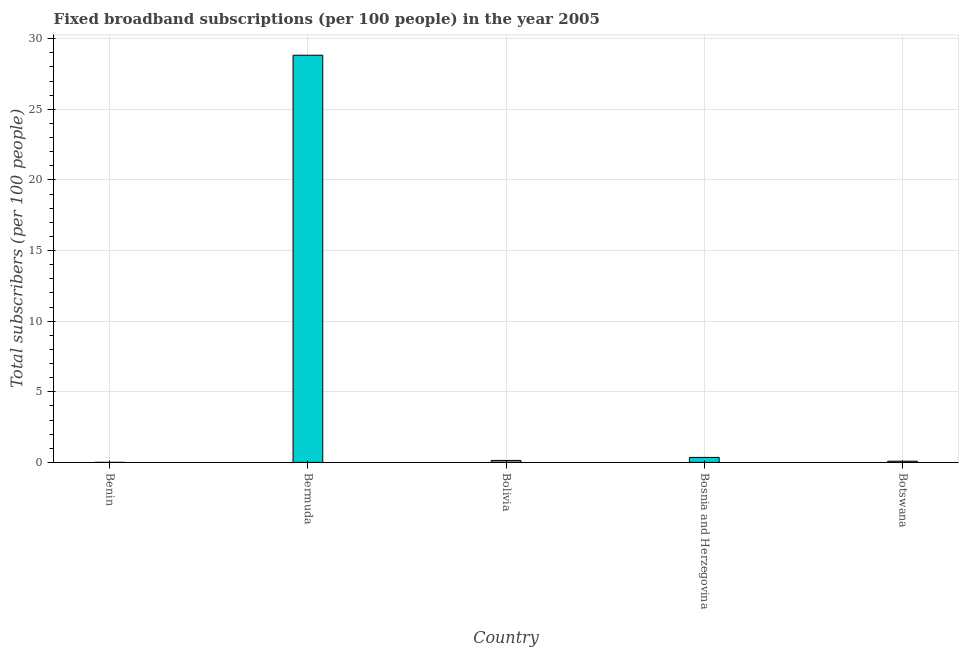Does the graph contain grids?
Give a very brief answer. Yes. What is the title of the graph?
Your answer should be compact. Fixed broadband subscriptions (per 100 people) in the year 2005. What is the label or title of the X-axis?
Provide a succinct answer. Country. What is the label or title of the Y-axis?
Offer a terse response. Total subscribers (per 100 people). What is the total number of fixed broadband subscriptions in Botswana?
Provide a succinct answer. 0.09. Across all countries, what is the maximum total number of fixed broadband subscriptions?
Make the answer very short. 28.82. Across all countries, what is the minimum total number of fixed broadband subscriptions?
Ensure brevity in your answer.  0. In which country was the total number of fixed broadband subscriptions maximum?
Offer a terse response. Bermuda. In which country was the total number of fixed broadband subscriptions minimum?
Make the answer very short. Benin. What is the sum of the total number of fixed broadband subscriptions?
Make the answer very short. 29.4. What is the difference between the total number of fixed broadband subscriptions in Bolivia and Bosnia and Herzegovina?
Your response must be concise. -0.21. What is the average total number of fixed broadband subscriptions per country?
Make the answer very short. 5.88. What is the median total number of fixed broadband subscriptions?
Offer a terse response. 0.14. What is the ratio of the total number of fixed broadband subscriptions in Bermuda to that in Bosnia and Herzegovina?
Your answer should be very brief. 81.62. Is the total number of fixed broadband subscriptions in Bermuda less than that in Bosnia and Herzegovina?
Provide a short and direct response. No. Is the difference between the total number of fixed broadband subscriptions in Bermuda and Bolivia greater than the difference between any two countries?
Your response must be concise. No. What is the difference between the highest and the second highest total number of fixed broadband subscriptions?
Provide a succinct answer. 28.47. What is the difference between the highest and the lowest total number of fixed broadband subscriptions?
Provide a short and direct response. 28.82. In how many countries, is the total number of fixed broadband subscriptions greater than the average total number of fixed broadband subscriptions taken over all countries?
Your answer should be compact. 1. What is the difference between two consecutive major ticks on the Y-axis?
Offer a terse response. 5. Are the values on the major ticks of Y-axis written in scientific E-notation?
Your answer should be compact. No. What is the Total subscribers (per 100 people) of Benin?
Offer a very short reply. 0. What is the Total subscribers (per 100 people) in Bermuda?
Offer a very short reply. 28.82. What is the Total subscribers (per 100 people) in Bolivia?
Provide a succinct answer. 0.14. What is the Total subscribers (per 100 people) of Bosnia and Herzegovina?
Your answer should be compact. 0.35. What is the Total subscribers (per 100 people) of Botswana?
Provide a succinct answer. 0.09. What is the difference between the Total subscribers (per 100 people) in Benin and Bermuda?
Ensure brevity in your answer.  -28.82. What is the difference between the Total subscribers (per 100 people) in Benin and Bolivia?
Provide a short and direct response. -0.14. What is the difference between the Total subscribers (per 100 people) in Benin and Bosnia and Herzegovina?
Offer a terse response. -0.35. What is the difference between the Total subscribers (per 100 people) in Benin and Botswana?
Provide a succinct answer. -0.08. What is the difference between the Total subscribers (per 100 people) in Bermuda and Bolivia?
Your response must be concise. 28.69. What is the difference between the Total subscribers (per 100 people) in Bermuda and Bosnia and Herzegovina?
Your answer should be very brief. 28.47. What is the difference between the Total subscribers (per 100 people) in Bermuda and Botswana?
Your answer should be compact. 28.74. What is the difference between the Total subscribers (per 100 people) in Bolivia and Bosnia and Herzegovina?
Give a very brief answer. -0.21. What is the difference between the Total subscribers (per 100 people) in Bolivia and Botswana?
Your response must be concise. 0.05. What is the difference between the Total subscribers (per 100 people) in Bosnia and Herzegovina and Botswana?
Your response must be concise. 0.27. What is the ratio of the Total subscribers (per 100 people) in Benin to that in Bolivia?
Your answer should be compact. 0.02. What is the ratio of the Total subscribers (per 100 people) in Benin to that in Bosnia and Herzegovina?
Your answer should be very brief. 0.01. What is the ratio of the Total subscribers (per 100 people) in Benin to that in Botswana?
Provide a short and direct response. 0.03. What is the ratio of the Total subscribers (per 100 people) in Bermuda to that in Bolivia?
Offer a very short reply. 207.85. What is the ratio of the Total subscribers (per 100 people) in Bermuda to that in Bosnia and Herzegovina?
Make the answer very short. 81.62. What is the ratio of the Total subscribers (per 100 people) in Bermuda to that in Botswana?
Provide a succinct answer. 337.93. What is the ratio of the Total subscribers (per 100 people) in Bolivia to that in Bosnia and Herzegovina?
Offer a very short reply. 0.39. What is the ratio of the Total subscribers (per 100 people) in Bolivia to that in Botswana?
Offer a terse response. 1.63. What is the ratio of the Total subscribers (per 100 people) in Bosnia and Herzegovina to that in Botswana?
Ensure brevity in your answer.  4.14. 